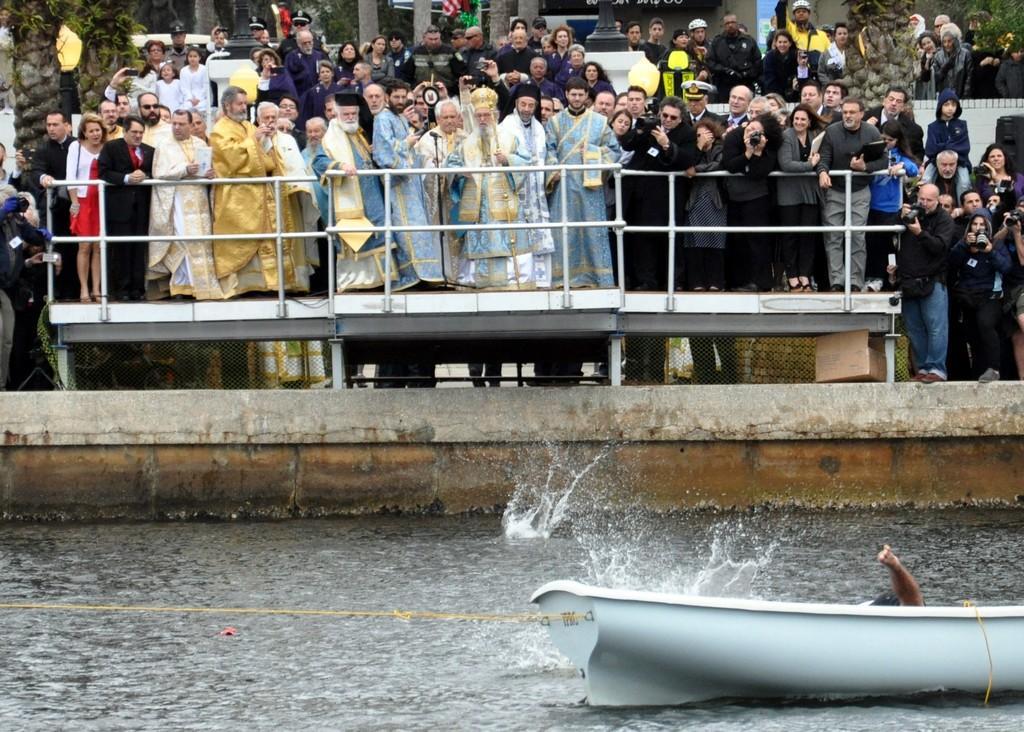In one or two sentences, can you explain what this image depicts? As we can see in the image there is water, boat, few people standing here and there, buildings and few of them are holding cameras. 